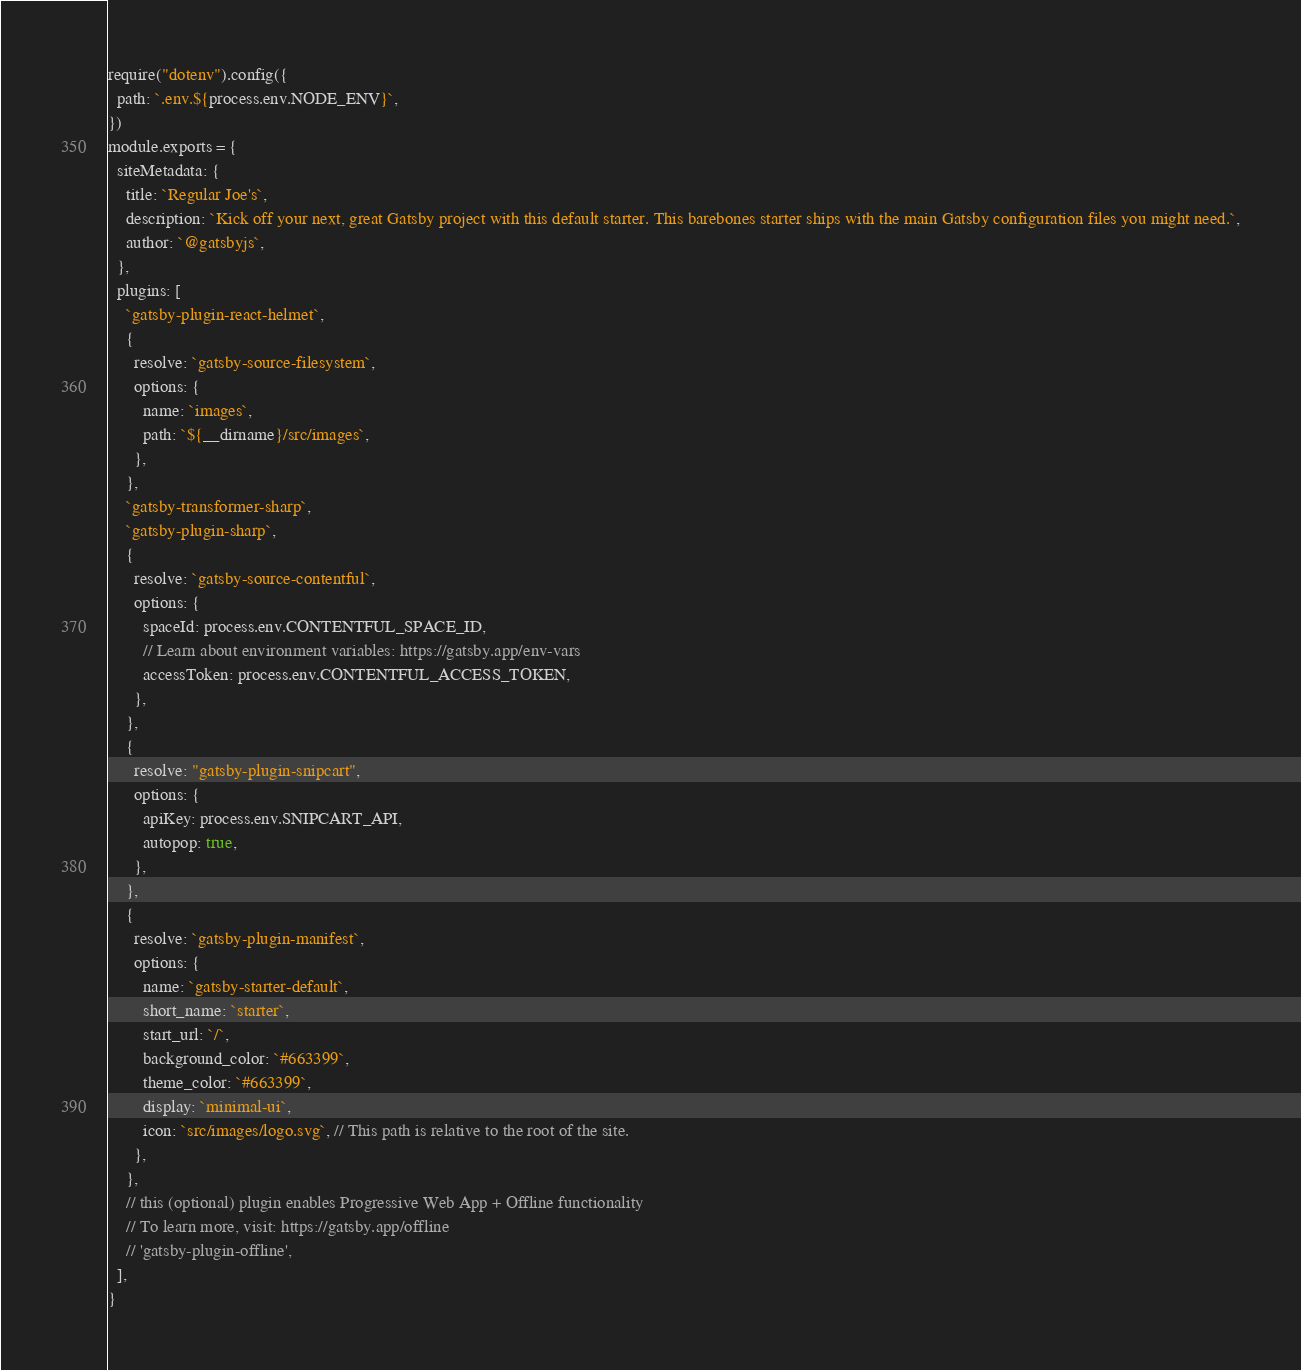Convert code to text. <code><loc_0><loc_0><loc_500><loc_500><_JavaScript_>require("dotenv").config({
  path: `.env.${process.env.NODE_ENV}`,
})
module.exports = {
  siteMetadata: {
    title: `Regular Joe's`,
    description: `Kick off your next, great Gatsby project with this default starter. This barebones starter ships with the main Gatsby configuration files you might need.`,
    author: `@gatsbyjs`,
  },
  plugins: [
    `gatsby-plugin-react-helmet`,
    {
      resolve: `gatsby-source-filesystem`,
      options: {
        name: `images`,
        path: `${__dirname}/src/images`,
      },
    },
    `gatsby-transformer-sharp`,
    `gatsby-plugin-sharp`,
    {
      resolve: `gatsby-source-contentful`,
      options: {
        spaceId: process.env.CONTENTFUL_SPACE_ID,
        // Learn about environment variables: https://gatsby.app/env-vars
        accessToken: process.env.CONTENTFUL_ACCESS_TOKEN,
      },
    },
    {
      resolve: "gatsby-plugin-snipcart",
      options: {
        apiKey: process.env.SNIPCART_API,
        autopop: true,
      },
    },
    {
      resolve: `gatsby-plugin-manifest`,
      options: {
        name: `gatsby-starter-default`,
        short_name: `starter`,
        start_url: `/`,
        background_color: `#663399`,
        theme_color: `#663399`,
        display: `minimal-ui`,
        icon: `src/images/logo.svg`, // This path is relative to the root of the site.
      },
    },
    // this (optional) plugin enables Progressive Web App + Offline functionality
    // To learn more, visit: https://gatsby.app/offline
    // 'gatsby-plugin-offline',
  ],
}
</code> 